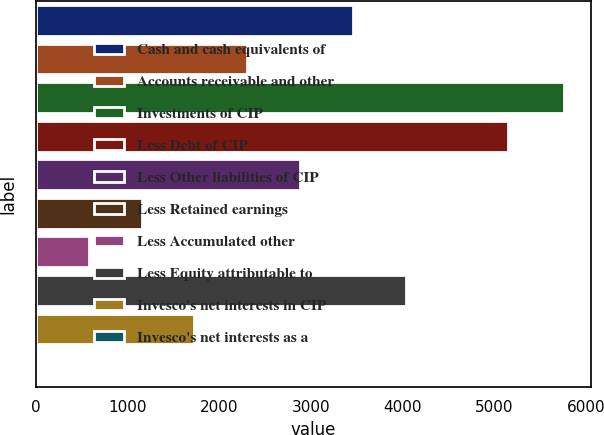<chart> <loc_0><loc_0><loc_500><loc_500><bar_chart><fcel>Cash and cash equivalents of<fcel>Accounts receivable and other<fcel>Investments of CIP<fcel>Less Debt of CIP<fcel>Less Other liabilities of CIP<fcel>Less Retained earnings<fcel>Less Accumulated other<fcel>Less Equity attributable to<fcel>Invesco's net interests in CIP<fcel>Invesco's net interests as a<nl><fcel>3458.36<fcel>2306.14<fcel>5762.8<fcel>5149.6<fcel>2882.25<fcel>1153.92<fcel>577.81<fcel>4034.47<fcel>1730.03<fcel>1.7<nl></chart> 